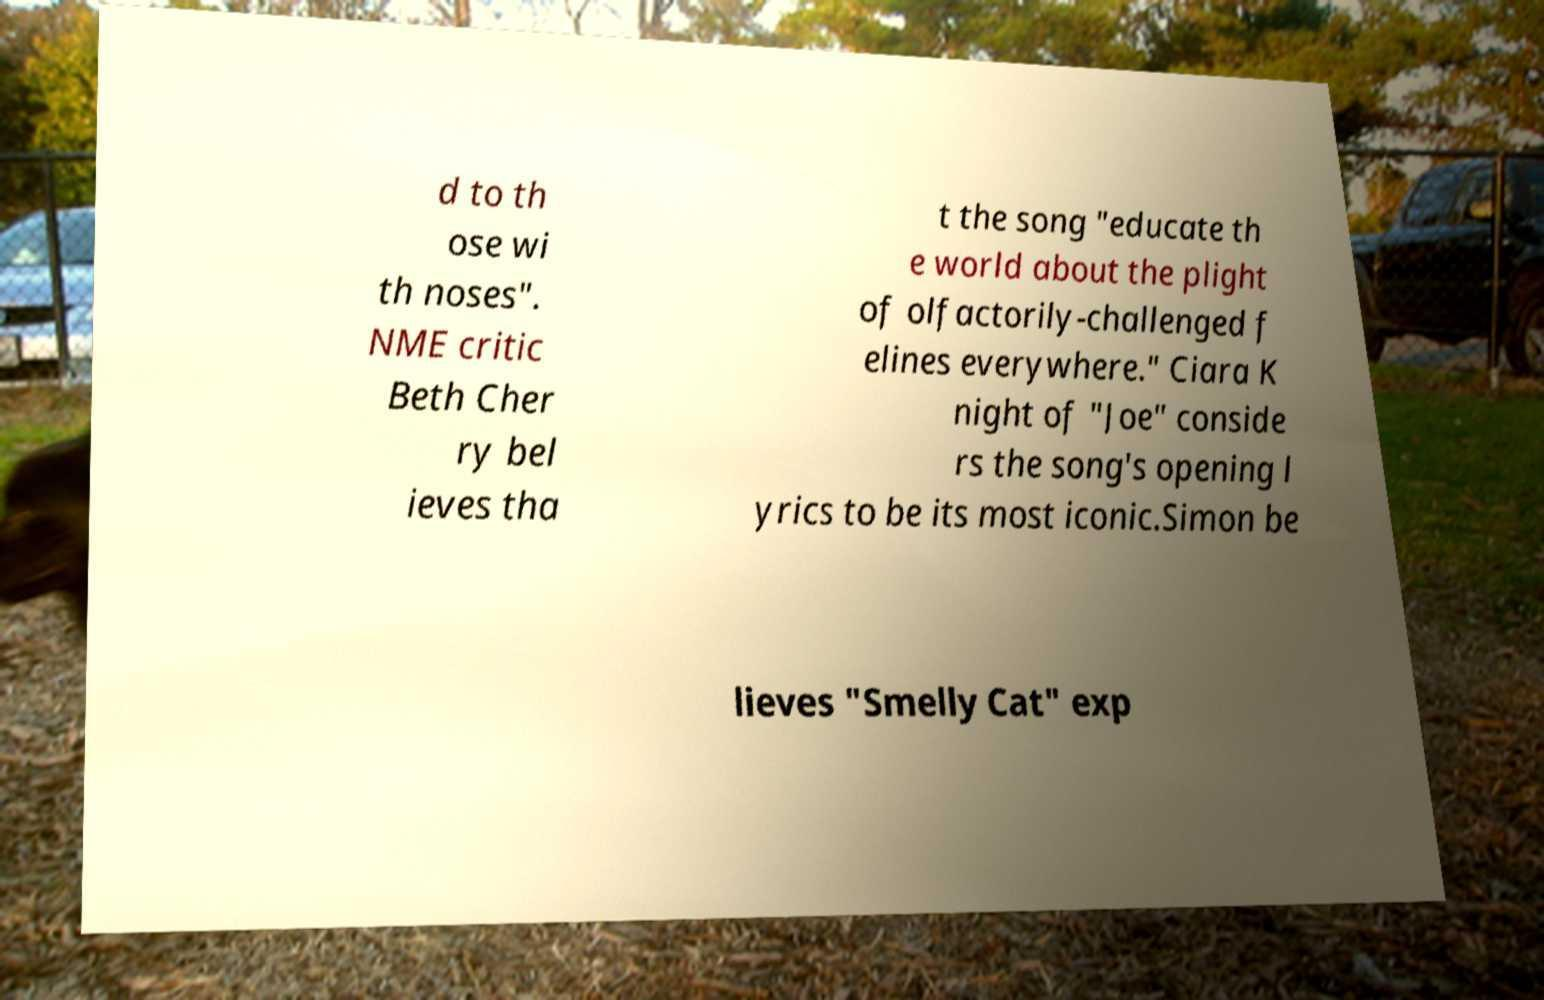Can you read and provide the text displayed in the image?This photo seems to have some interesting text. Can you extract and type it out for me? d to th ose wi th noses". NME critic Beth Cher ry bel ieves tha t the song "educate th e world about the plight of olfactorily-challenged f elines everywhere." Ciara K night of "Joe" conside rs the song's opening l yrics to be its most iconic.Simon be lieves "Smelly Cat" exp 